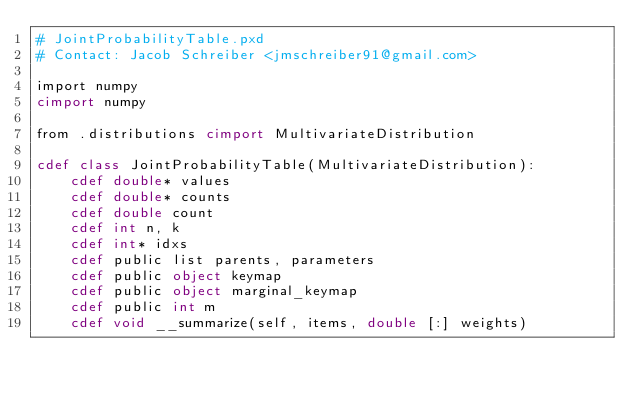<code> <loc_0><loc_0><loc_500><loc_500><_Cython_># JointProbabilityTable.pxd
# Contact: Jacob Schreiber <jmschreiber91@gmail.com>

import numpy
cimport numpy

from .distributions cimport MultivariateDistribution

cdef class JointProbabilityTable(MultivariateDistribution):
	cdef double* values
	cdef double* counts
	cdef double count
	cdef int n, k
	cdef int* idxs
	cdef public list parents, parameters
	cdef public object keymap
	cdef public object marginal_keymap
	cdef public int m
	cdef void __summarize(self, items, double [:] weights)

</code> 